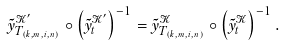<formula> <loc_0><loc_0><loc_500><loc_500>\tilde { y } _ { T _ { ( k , m , i , n ) } } ^ { \mathcal { K } ^ { \prime } } \circ \left ( \tilde { y } _ { t } ^ { \mathcal { K } ^ { \prime } } \right ) ^ { - 1 } = \tilde { y } _ { T _ { ( k , m , i , n ) } } ^ { \mathcal { K } } \circ \left ( \tilde { y } _ { t } ^ { \mathcal { K } } \right ) ^ { - 1 } .</formula> 